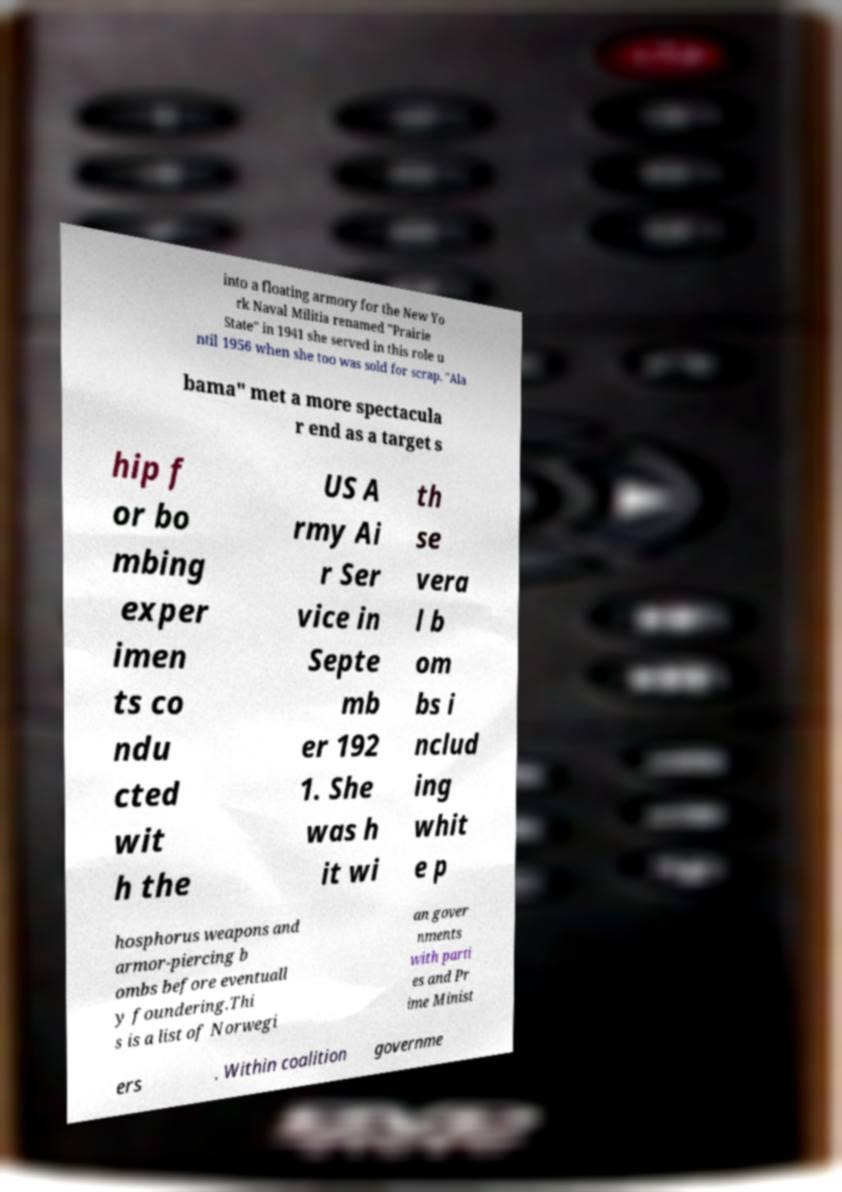There's text embedded in this image that I need extracted. Can you transcribe it verbatim? into a floating armory for the New Yo rk Naval Militia renamed "Prairie State" in 1941 she served in this role u ntil 1956 when she too was sold for scrap. "Ala bama" met a more spectacula r end as a target s hip f or bo mbing exper imen ts co ndu cted wit h the US A rmy Ai r Ser vice in Septe mb er 192 1. She was h it wi th se vera l b om bs i nclud ing whit e p hosphorus weapons and armor-piercing b ombs before eventuall y foundering.Thi s is a list of Norwegi an gover nments with parti es and Pr ime Minist ers . Within coalition governme 